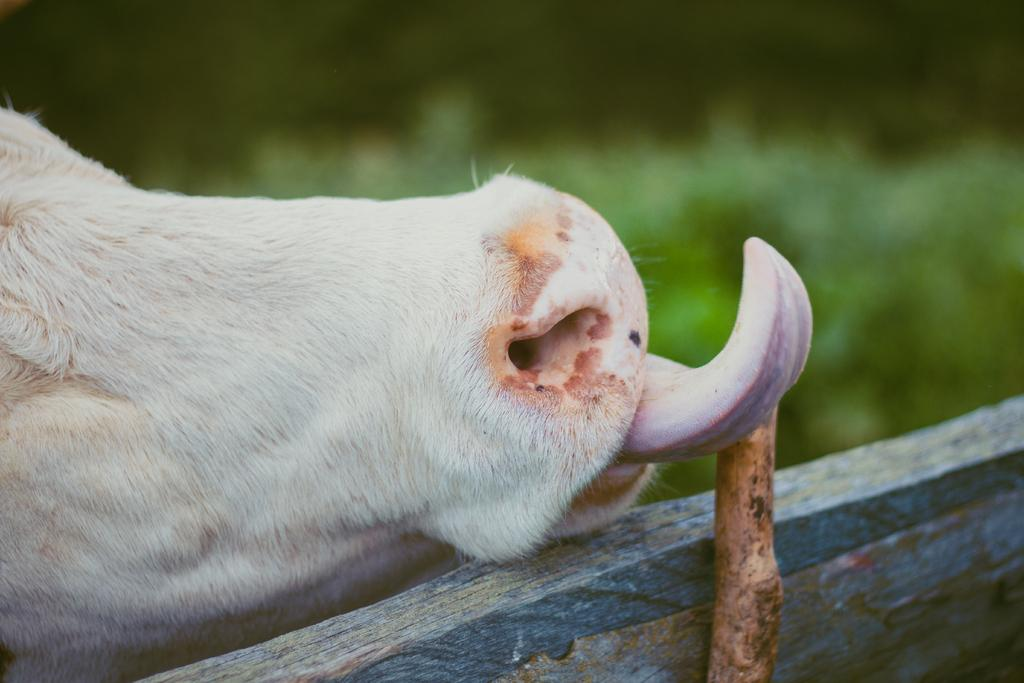What part of an animal or person can be seen in the image? There is a tongue visible in the image. What color is the animal's nose in the image? The animal's nose in the image is white. What color is the background of the image? The background of the image is green. How would you describe the quality of the image? The image is slightly blurry in the background. How much sugar is present in the air in the image? There is no indication of sugar or pollution in the image; it only shows a tongue and an animal's nose with a green background. 